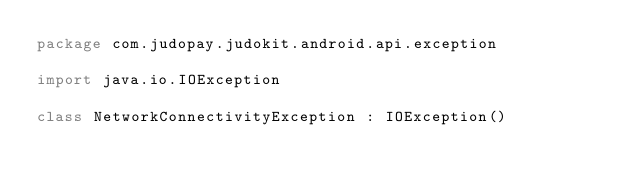<code> <loc_0><loc_0><loc_500><loc_500><_Kotlin_>package com.judopay.judokit.android.api.exception

import java.io.IOException

class NetworkConnectivityException : IOException()
</code> 